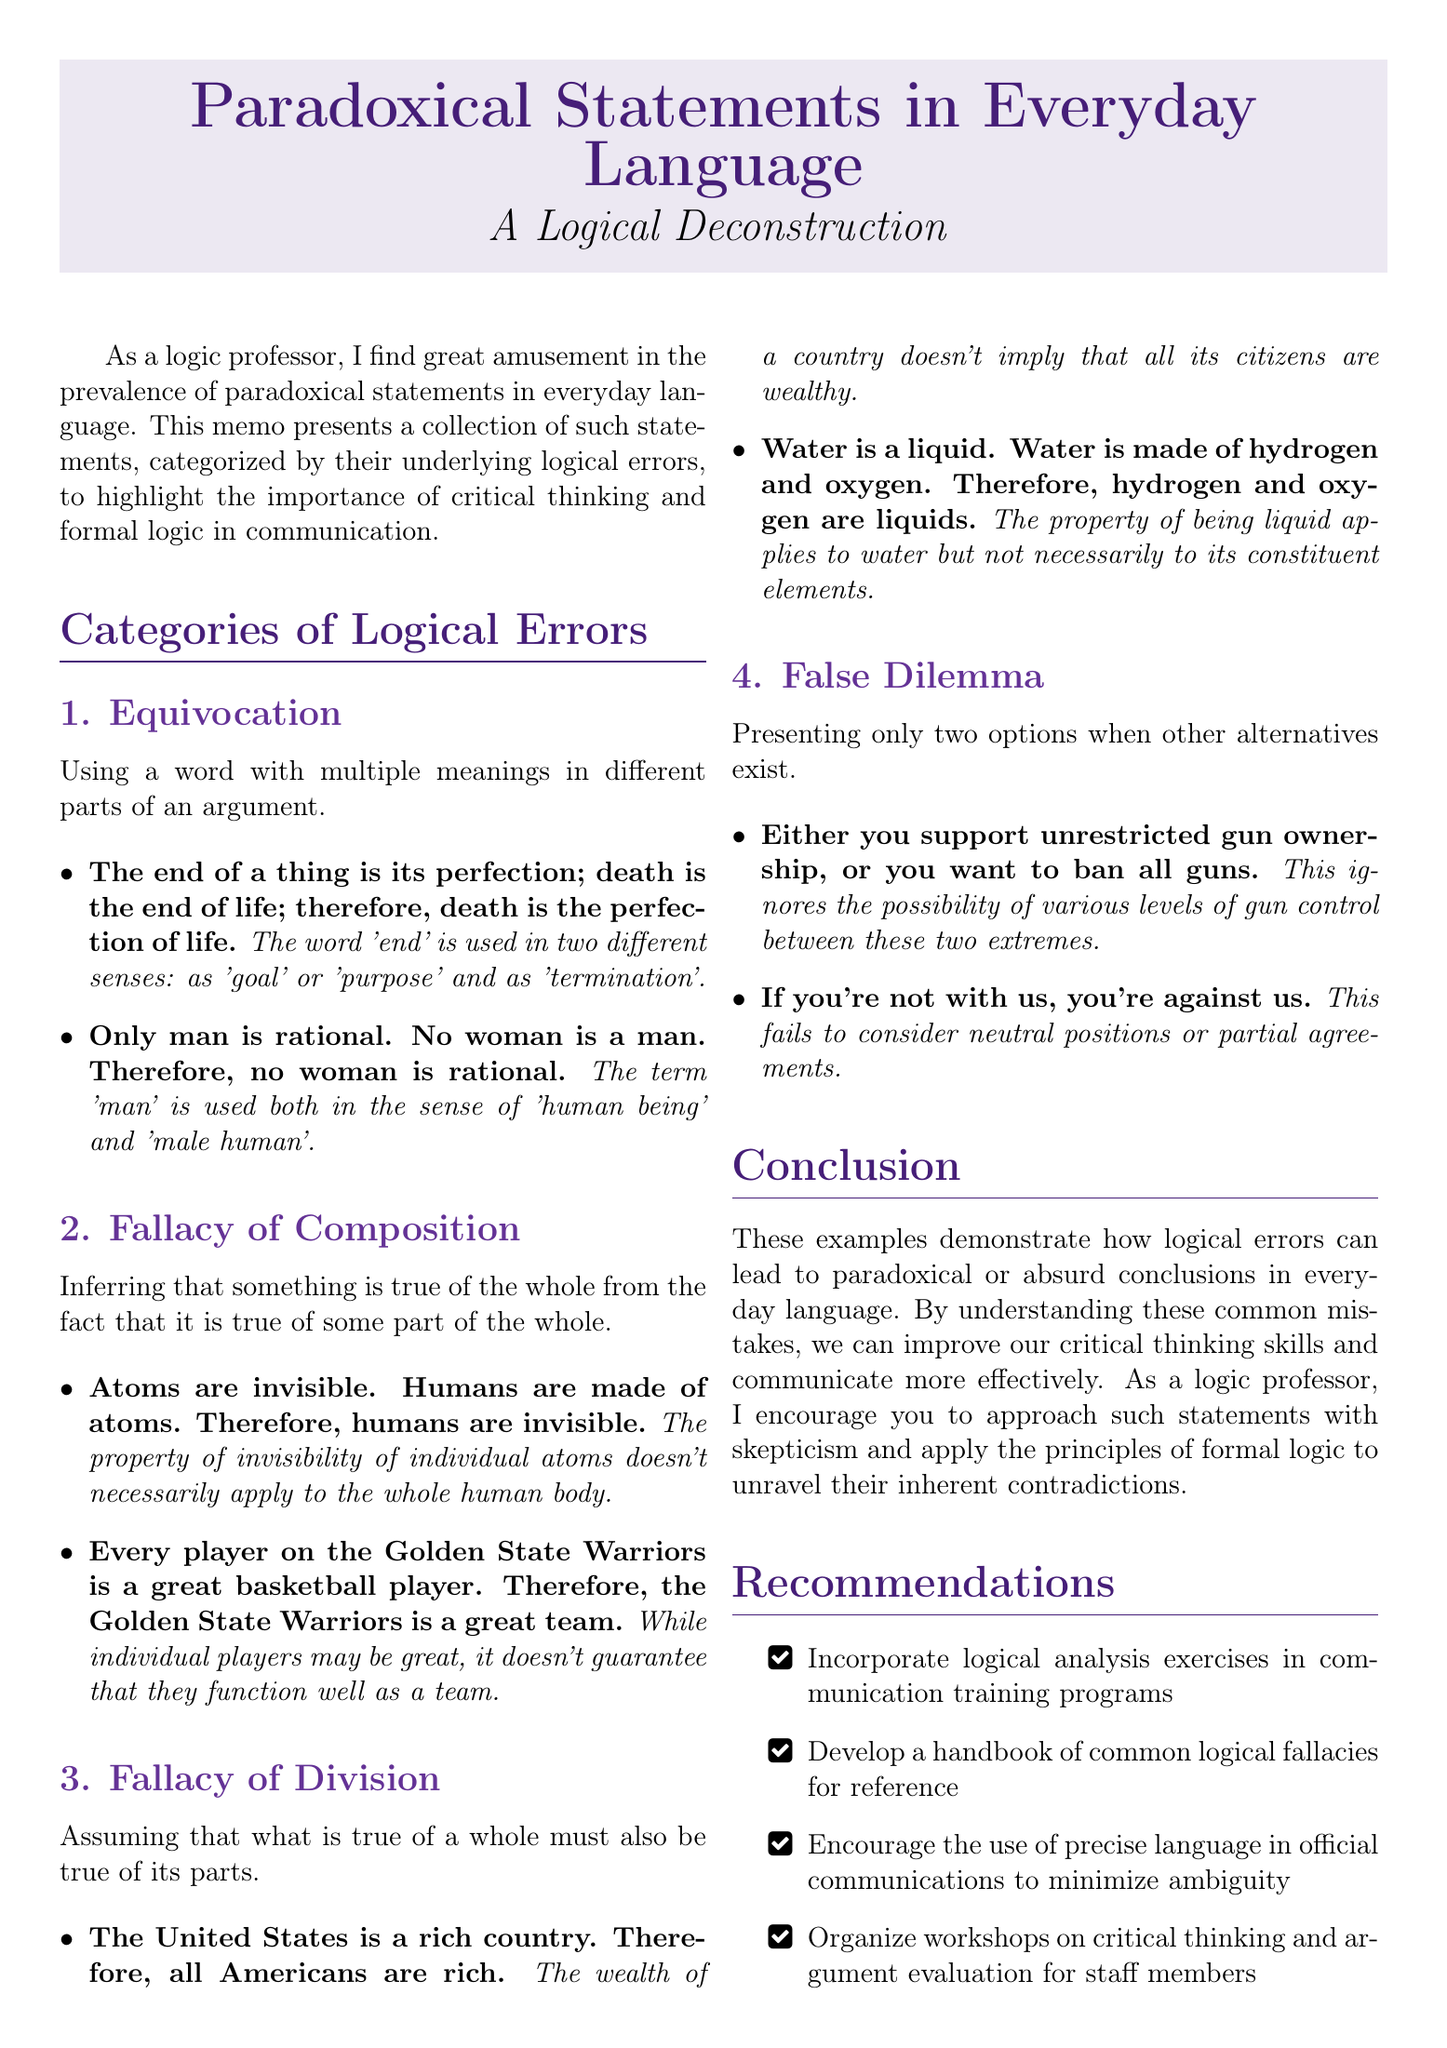What is the title of the memo? The title of the memo is found at the beginning of the document.
Answer: Paradoxical Statements in Everyday Language: A Logical Deconstruction How many categories of logical errors are listed? The document enumerates the sections to identify categories.
Answer: 4 What is the second category of logical errors? The second category is specified in a numbered list within the memo.
Answer: Fallacy of Composition What logical error is exemplified by the statement about the Golden State Warriors? This question refers to specific examples provided for each category.
Answer: Fallacy of Composition What does the first example under Equivocation use in different senses? The explanation details the specific term that contributes to the logical error in the example.
Answer: end Which word is used in two different senses in the second example under Equivocation? This question targets a specific word utilized in the provided example.
Answer: man What is recommended to minimize ambiguity in official communications? The recommendation section specifies ways to improve communication clarity.
Answer: Encourage the use of precise language What kind of exercises are suggested in the recommendations? The memo outlines specific types of training activities for improvement.
Answer: logical analysis exercises 